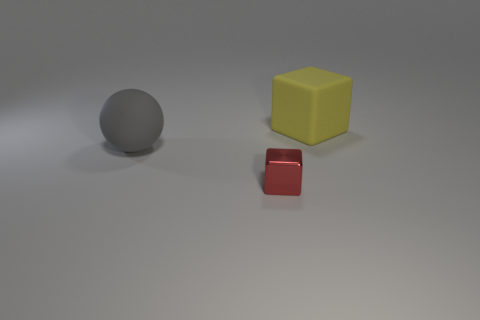Can you describe the lighting and shadows seen in this image? The scene is illuminated with what appears to be diffuse overhead lighting, casting soft shadows that are less intense directly underneath each object and becoming slightly elongated as they move away from the base, suggesting that the light source is not positioned directly above the objects. This lighting contributes to a calm and balanced atmosphere in the image. 